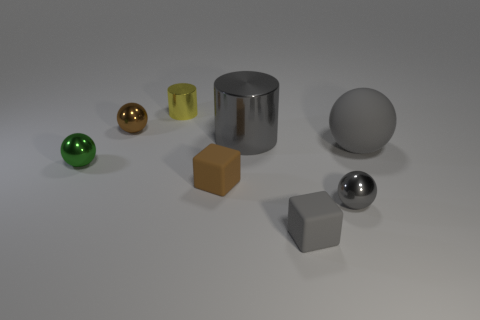What number of brown metal objects are there?
Ensure brevity in your answer.  1. There is a gray matte object behind the small green object left of the gray matte ball; what is its size?
Make the answer very short. Large. What number of other things are the same size as the gray matte block?
Your answer should be very brief. 5. There is a large cylinder; what number of tiny matte objects are to the right of it?
Provide a short and direct response. 1. The gray rubber sphere has what size?
Offer a terse response. Large. Is the material of the small sphere to the right of the tiny gray cube the same as the cylinder right of the tiny cylinder?
Make the answer very short. Yes. Is there a rubber thing of the same color as the rubber sphere?
Your answer should be compact. Yes. There is another rubber thing that is the same size as the brown rubber thing; what color is it?
Keep it short and to the point. Gray. Do the large thing on the right side of the big metallic thing and the big metal cylinder have the same color?
Provide a short and direct response. Yes. Is there a brown thing made of the same material as the gray cylinder?
Your answer should be compact. Yes. 